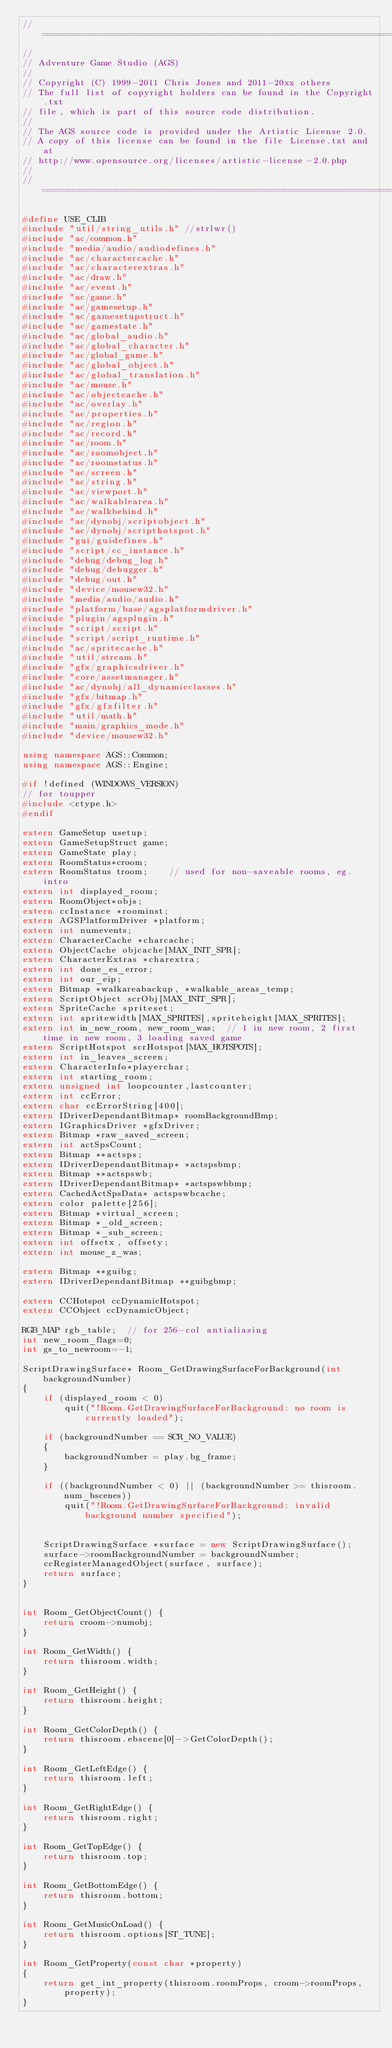<code> <loc_0><loc_0><loc_500><loc_500><_C++_>//=============================================================================
//
// Adventure Game Studio (AGS)
//
// Copyright (C) 1999-2011 Chris Jones and 2011-20xx others
// The full list of copyright holders can be found in the Copyright.txt
// file, which is part of this source code distribution.
//
// The AGS source code is provided under the Artistic License 2.0.
// A copy of this license can be found in the file License.txt and at
// http://www.opensource.org/licenses/artistic-license-2.0.php
//
//=============================================================================

#define USE_CLIB
#include "util/string_utils.h" //strlwr()
#include "ac/common.h"
#include "media/audio/audiodefines.h"
#include "ac/charactercache.h"
#include "ac/characterextras.h"
#include "ac/draw.h"
#include "ac/event.h"
#include "ac/game.h"
#include "ac/gamesetup.h"
#include "ac/gamesetupstruct.h"
#include "ac/gamestate.h"
#include "ac/global_audio.h"
#include "ac/global_character.h"
#include "ac/global_game.h"
#include "ac/global_object.h"
#include "ac/global_translation.h"
#include "ac/mouse.h"
#include "ac/objectcache.h"
#include "ac/overlay.h"
#include "ac/properties.h"
#include "ac/region.h"
#include "ac/record.h"
#include "ac/room.h"
#include "ac/roomobject.h"
#include "ac/roomstatus.h"
#include "ac/screen.h"
#include "ac/string.h"
#include "ac/viewport.h"
#include "ac/walkablearea.h"
#include "ac/walkbehind.h"
#include "ac/dynobj/scriptobject.h"
#include "ac/dynobj/scripthotspot.h"
#include "gui/guidefines.h"
#include "script/cc_instance.h"
#include "debug/debug_log.h"
#include "debug/debugger.h"
#include "debug/out.h"
#include "device/mousew32.h"
#include "media/audio/audio.h"
#include "platform/base/agsplatformdriver.h"
#include "plugin/agsplugin.h"
#include "script/script.h"
#include "script/script_runtime.h"
#include "ac/spritecache.h"
#include "util/stream.h"
#include "gfx/graphicsdriver.h"
#include "core/assetmanager.h"
#include "ac/dynobj/all_dynamicclasses.h"
#include "gfx/bitmap.h"
#include "gfx/gfxfilter.h"
#include "util/math.h"
#include "main/graphics_mode.h"
#include "device/mousew32.h"

using namespace AGS::Common;
using namespace AGS::Engine;

#if !defined (WINDOWS_VERSION)
// for toupper
#include <ctype.h>
#endif

extern GameSetup usetup;
extern GameSetupStruct game;
extern GameState play;
extern RoomStatus*croom;
extern RoomStatus troom;    // used for non-saveable rooms, eg. intro
extern int displayed_room;
extern RoomObject*objs;
extern ccInstance *roominst;
extern AGSPlatformDriver *platform;
extern int numevents;
extern CharacterCache *charcache;
extern ObjectCache objcache[MAX_INIT_SPR];
extern CharacterExtras *charextra;
extern int done_es_error;
extern int our_eip;
extern Bitmap *walkareabackup, *walkable_areas_temp;
extern ScriptObject scrObj[MAX_INIT_SPR];
extern SpriteCache spriteset;
extern int spritewidth[MAX_SPRITES],spriteheight[MAX_SPRITES];
extern int in_new_room, new_room_was;  // 1 in new room, 2 first time in new room, 3 loading saved game
extern ScriptHotspot scrHotspot[MAX_HOTSPOTS];
extern int in_leaves_screen;
extern CharacterInfo*playerchar;
extern int starting_room;
extern unsigned int loopcounter,lastcounter;
extern int ccError;
extern char ccErrorString[400];
extern IDriverDependantBitmap* roomBackgroundBmp;
extern IGraphicsDriver *gfxDriver;
extern Bitmap *raw_saved_screen;
extern int actSpsCount;
extern Bitmap **actsps;
extern IDriverDependantBitmap* *actspsbmp;
extern Bitmap **actspswb;
extern IDriverDependantBitmap* *actspswbbmp;
extern CachedActSpsData* actspswbcache;
extern color palette[256];
extern Bitmap *virtual_screen;
extern Bitmap *_old_screen;
extern Bitmap *_sub_screen;
extern int offsetx, offsety;
extern int mouse_z_was;

extern Bitmap **guibg;
extern IDriverDependantBitmap **guibgbmp;

extern CCHotspot ccDynamicHotspot;
extern CCObject ccDynamicObject;

RGB_MAP rgb_table;  // for 256-col antialiasing
int new_room_flags=0;
int gs_to_newroom=-1;

ScriptDrawingSurface* Room_GetDrawingSurfaceForBackground(int backgroundNumber)
{
    if (displayed_room < 0)
        quit("!Room.GetDrawingSurfaceForBackground: no room is currently loaded");

    if (backgroundNumber == SCR_NO_VALUE)
    {
        backgroundNumber = play.bg_frame;
    }

    if ((backgroundNumber < 0) || (backgroundNumber >= thisroom.num_bscenes))
        quit("!Room.GetDrawingSurfaceForBackground: invalid background number specified");


    ScriptDrawingSurface *surface = new ScriptDrawingSurface();
    surface->roomBackgroundNumber = backgroundNumber;
    ccRegisterManagedObject(surface, surface);
    return surface;
}


int Room_GetObjectCount() {
    return croom->numobj;
}

int Room_GetWidth() {
    return thisroom.width;
}

int Room_GetHeight() {
    return thisroom.height;
}

int Room_GetColorDepth() {
    return thisroom.ebscene[0]->GetColorDepth();
}

int Room_GetLeftEdge() {
    return thisroom.left;
}

int Room_GetRightEdge() {
    return thisroom.right;
}

int Room_GetTopEdge() {
    return thisroom.top;
}

int Room_GetBottomEdge() {
    return thisroom.bottom;
}

int Room_GetMusicOnLoad() {
    return thisroom.options[ST_TUNE];
}

int Room_GetProperty(const char *property)
{
    return get_int_property(thisroom.roomProps, croom->roomProps, property);
}
</code> 